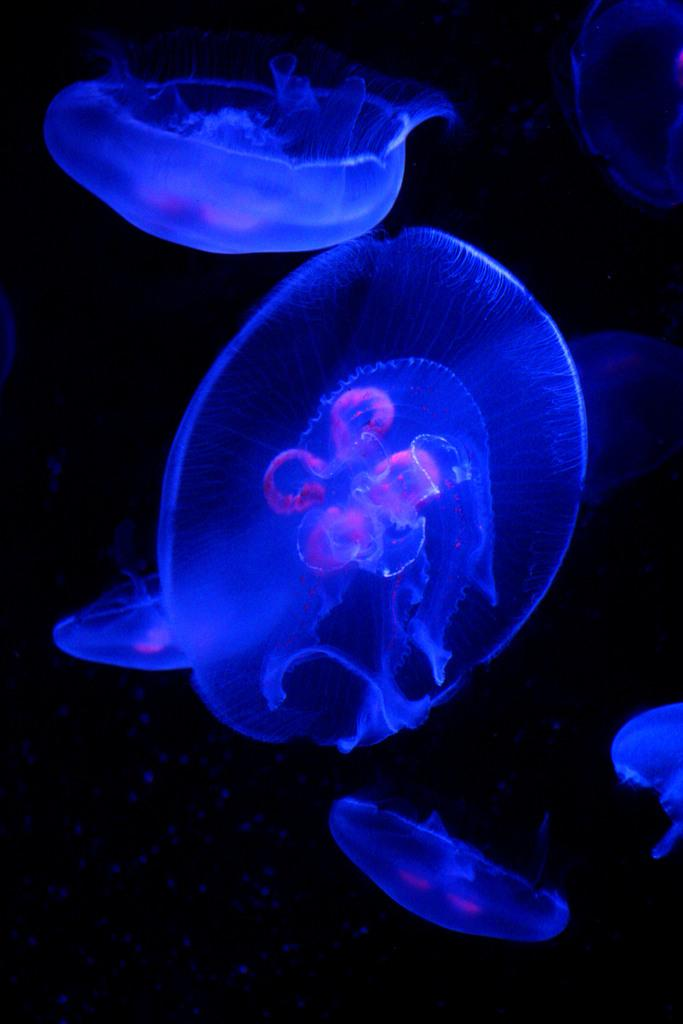What type of marine animals can be seen in the image? There are jellyfish in the water. What is the color of the background in the image? The background of the image is dark in color. What type of fruit can be seen hanging from the jellyfish in the image? There is no fruit hanging from the jellyfish in the image. What type of rock can be seen supporting the jellyfish in the image? There is no rock present in the image; it features jellyfish in the water. 